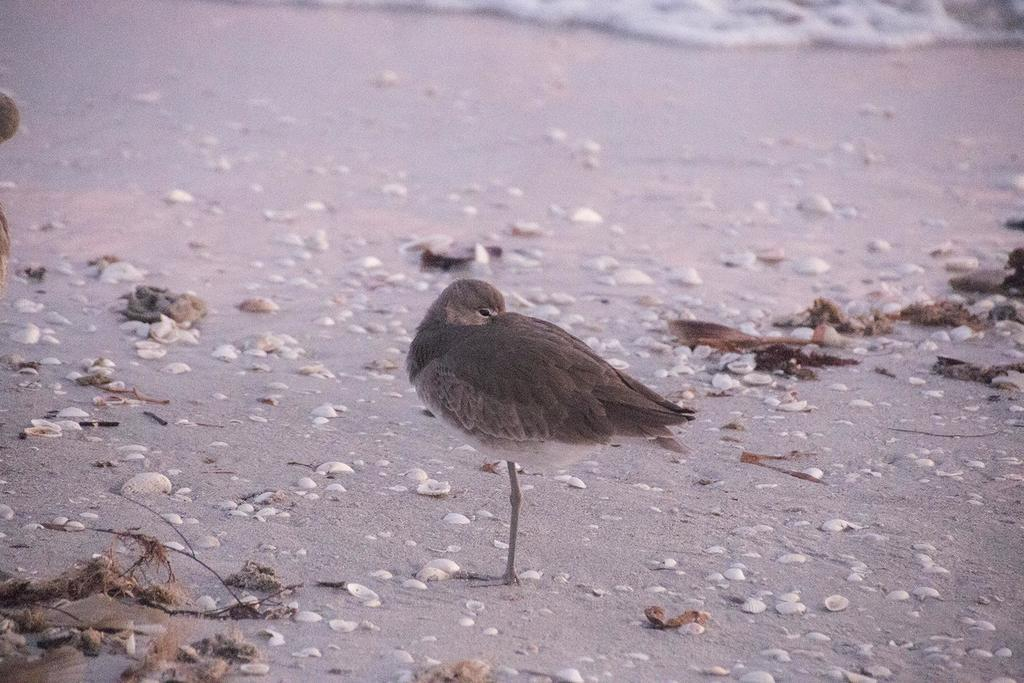What animal can be seen in the image? There is a bird standing on the sand in the image. What is the bird standing on? The bird is standing on the sand. What other objects are visible near the bird? There are many stones visible near the bird. What color are the objects near the bird? The objects near the bird have a brown color. What can be seen in the background of the image? There is water visible in the background of the image. What type of roof can be seen on the bird in the image? There is no roof present on the bird in the image; it is a bird standing on the sand. 